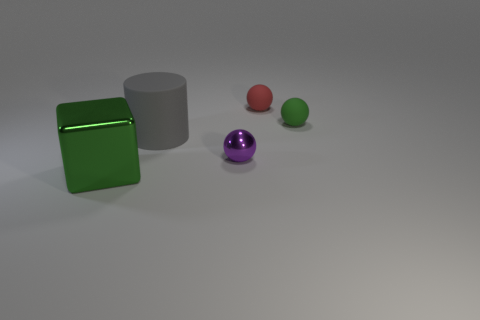There is a big metal thing; does it have the same shape as the green matte thing that is to the right of the cylinder?
Provide a short and direct response. No. Are there the same number of large gray cylinders on the right side of the gray matte thing and big shiny things right of the small purple ball?
Keep it short and to the point. Yes. What number of other objects are the same material as the gray cylinder?
Your answer should be compact. 2. What number of metal things are small cyan cylinders or large gray cylinders?
Offer a very short reply. 0. There is a green thing on the left side of the green matte sphere; does it have the same shape as the red matte object?
Keep it short and to the point. No. Is the number of rubber cylinders that are to the right of the purple metal thing greater than the number of tiny purple blocks?
Offer a very short reply. No. How many things are both to the left of the tiny green thing and right of the gray cylinder?
Your answer should be very brief. 2. What is the color of the thing right of the matte object behind the tiny green rubber thing?
Keep it short and to the point. Green. How many other big matte cylinders are the same color as the big cylinder?
Your response must be concise. 0. Does the big metallic object have the same color as the big thing that is behind the purple thing?
Your answer should be very brief. No. 